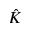Convert formula to latex. <formula><loc_0><loc_0><loc_500><loc_500>\hat { K }</formula> 